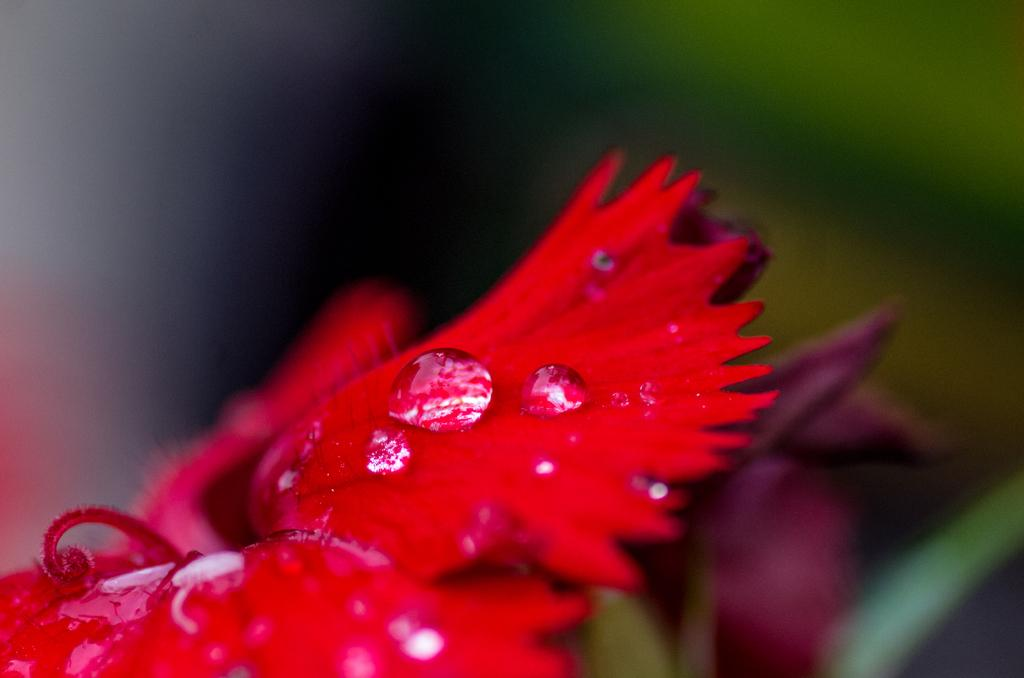What is present in the picture? There is a flower in the picture. Can you describe any additional details about the flower? There are water drops visible in the picture. What type of thread is being used to create the flower's petals in the image? There is no thread present in the image; the flower is a natural object. 